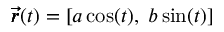Convert formula to latex. <formula><loc_0><loc_0><loc_500><loc_500>\pm b { \vec { r } } ( t ) = [ a \cos ( t ) , \, b \sin ( t ) ]</formula> 